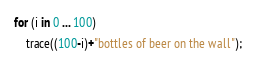<code> <loc_0><loc_0><loc_500><loc_500><_Haxe_>for (i in 0 ... 100)
	trace((100-i)+"bottles of beer on the wall");</code> 